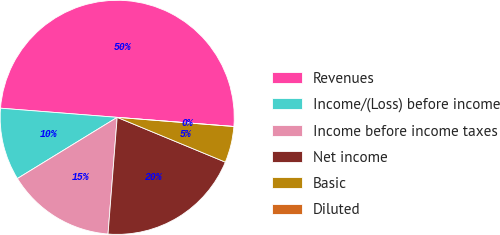Convert chart to OTSL. <chart><loc_0><loc_0><loc_500><loc_500><pie_chart><fcel>Revenues<fcel>Income/(Loss) before income<fcel>Income before income taxes<fcel>Net income<fcel>Basic<fcel>Diluted<nl><fcel>50.0%<fcel>10.0%<fcel>15.0%<fcel>20.0%<fcel>5.0%<fcel>0.0%<nl></chart> 